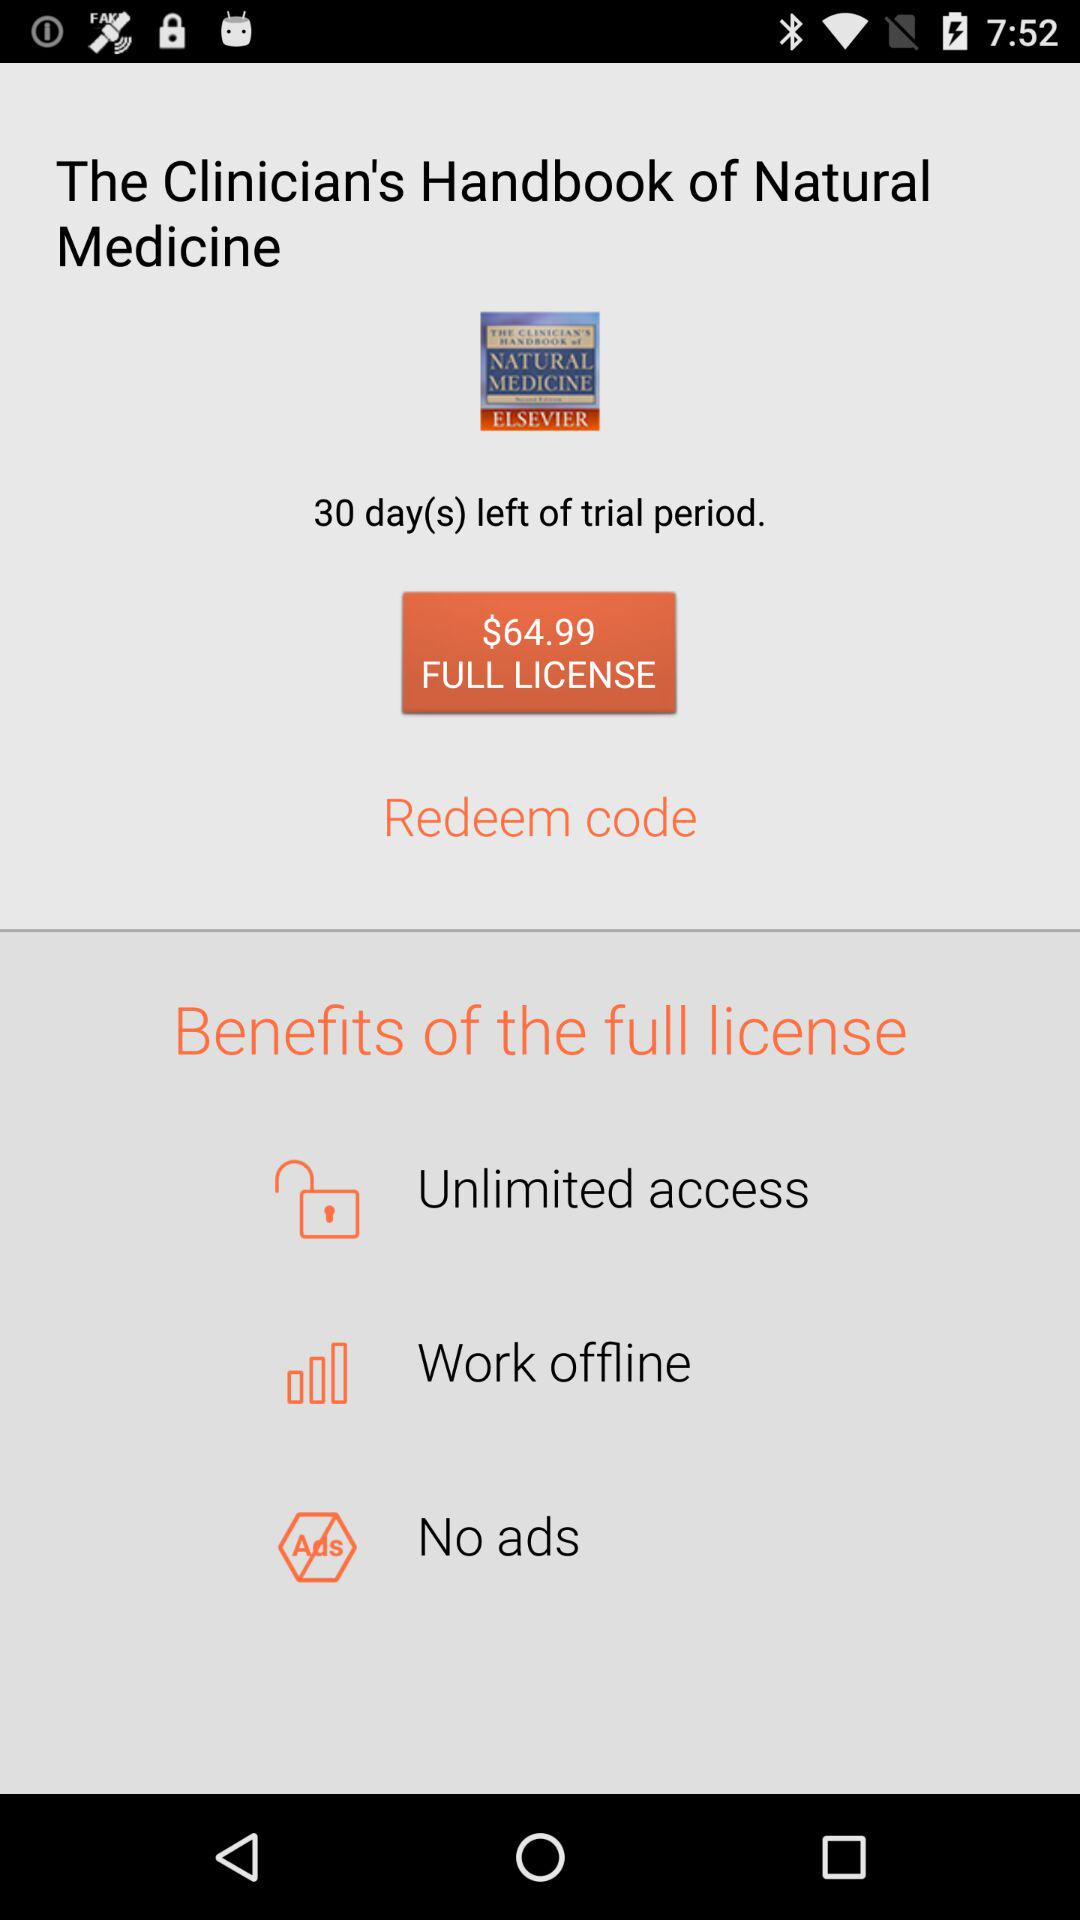What is the currency for the cost of the license? The currency is dollars. 